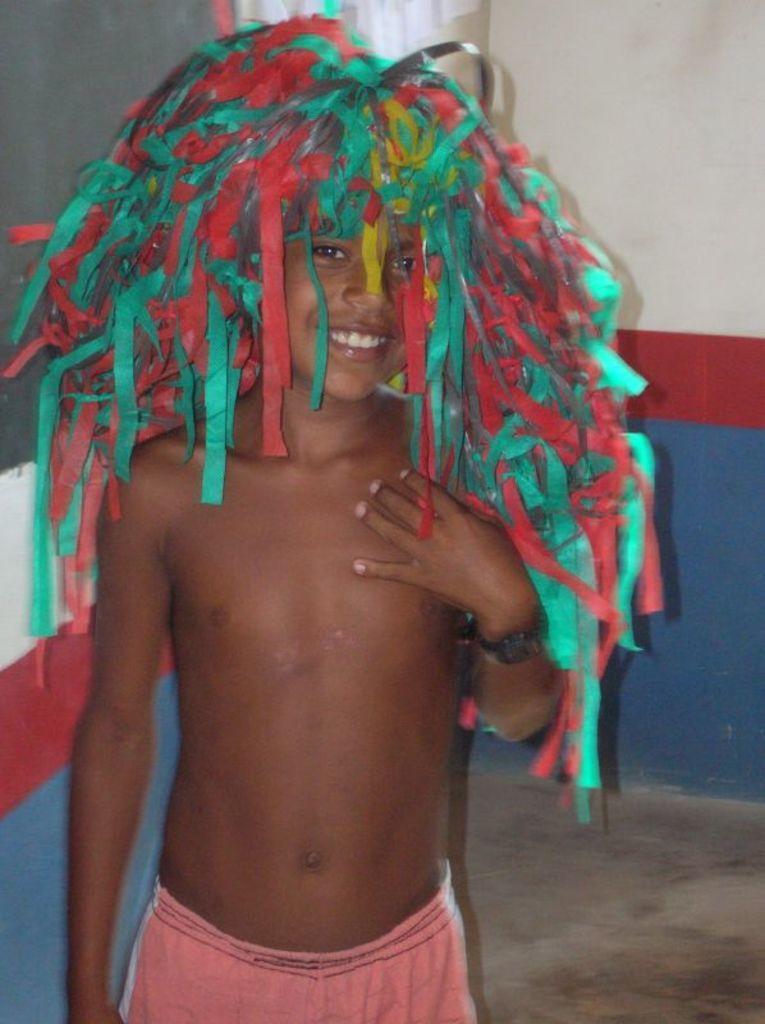How would you summarize this image in a sentence or two? In this picture, we see a boy who is wearing the costume is standing. He is smiling and he might be posing for the photo. In the background, we see a wall in white, blue and red color. 